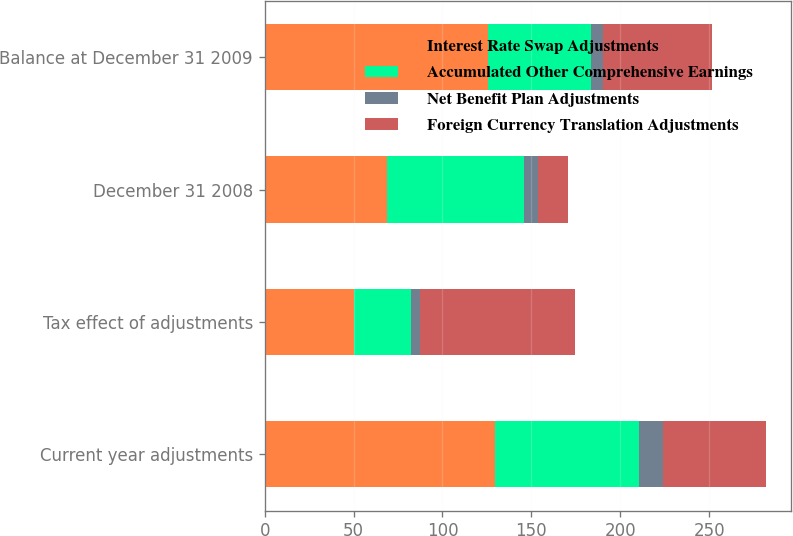Convert chart to OTSL. <chart><loc_0><loc_0><loc_500><loc_500><stacked_bar_chart><ecel><fcel>Current year adjustments<fcel>Tax effect of adjustments<fcel>December 31 2008<fcel>Balance at December 31 2009<nl><fcel>Interest Rate Swap Adjustments<fcel>129.6<fcel>50.1<fcel>68.6<fcel>125.8<nl><fcel>Accumulated Other Comprehensive Earnings<fcel>81<fcel>32<fcel>77.1<fcel>57.8<nl><fcel>Net Benefit Plan Adjustments<fcel>13.5<fcel>5.3<fcel>8.2<fcel>6.5<nl><fcel>Foreign Currency Translation Adjustments<fcel>57.8<fcel>87.4<fcel>16.7<fcel>61.5<nl></chart> 